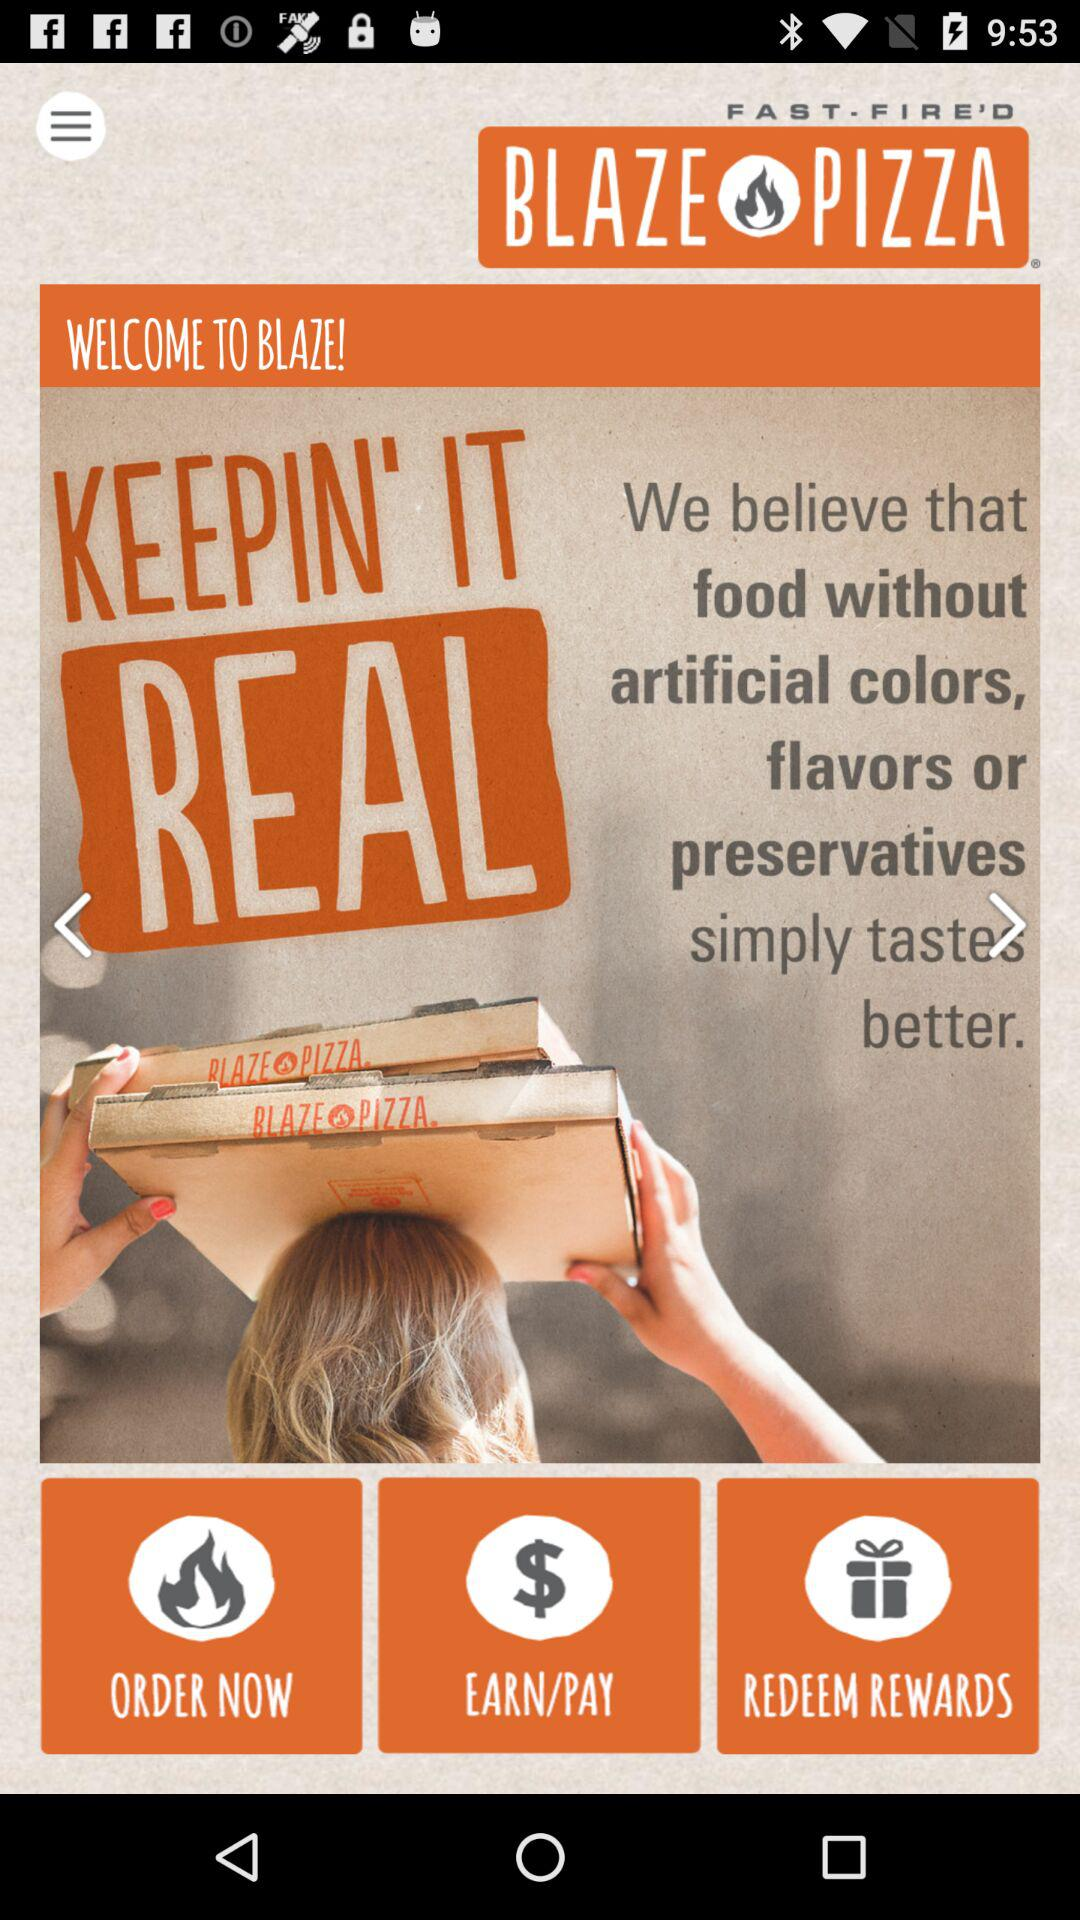What is the name of the application? The name of the application is "BLAZE PIZZA". 